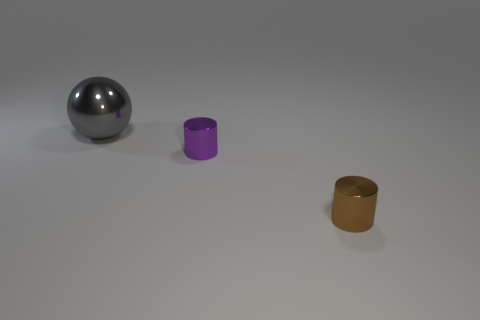There is a small object that is to the left of the shiny cylinder in front of the purple shiny object; is there a small brown metal cylinder that is in front of it?
Your answer should be compact. Yes. What number of other objects are there of the same shape as the brown shiny thing?
Provide a succinct answer. 1. There is a object that is in front of the gray sphere and to the left of the tiny brown cylinder; what is its shape?
Ensure brevity in your answer.  Cylinder. The metallic object to the left of the small metal cylinder behind the cylinder that is to the right of the purple metal cylinder is what color?
Your answer should be compact. Gray. Are there more things that are right of the gray ball than purple cylinders to the right of the tiny brown thing?
Ensure brevity in your answer.  Yes. How many other things are there of the same size as the purple metallic object?
Offer a very short reply. 1. Are there any brown objects in front of the large gray thing?
Keep it short and to the point. Yes. Is the number of tiny brown cylinders that are on the right side of the large metallic ball greater than the number of big rubber cylinders?
Provide a succinct answer. Yes. What color is the other cylinder that is the same size as the brown shiny cylinder?
Make the answer very short. Purple. Is there a gray metallic object to the left of the tiny shiny cylinder behind the brown shiny cylinder?
Ensure brevity in your answer.  Yes. 